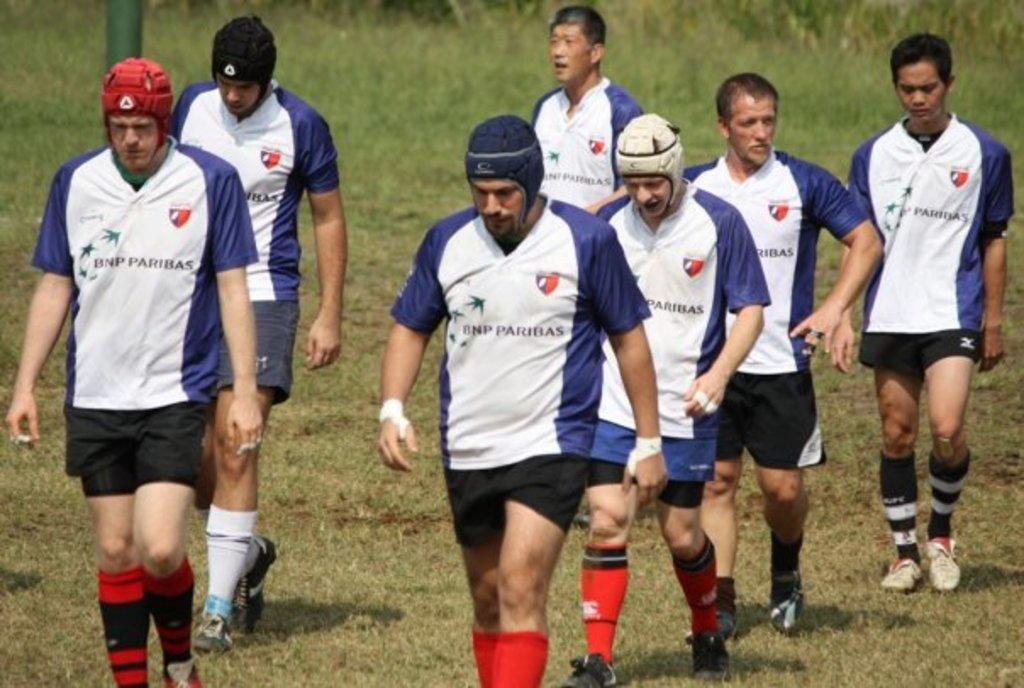What are the people in the image doing? The people in the image are walking. What are the people wearing on their feet? The people are wearing shoes. What are the people wearing on their hands? The people are wearing socks. What are the people wearing on their heads? Some people are wearing caps. What type of surface is visible in the image? There is grass visible in the image. What object can be seen in the image that is not related to the people? There is a pole in the image. What type of art can be seen on the pole in the image? There is no art visible on the pole in the image. What type of rod is being used by the people in the image? There is no rod being used by the people in the image. 